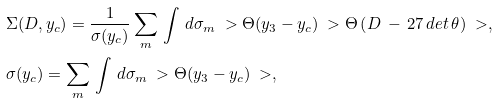<formula> <loc_0><loc_0><loc_500><loc_500>& \Sigma ( D , y _ { c } ) = \frac { 1 } { \sigma ( y _ { c } ) } \sum _ { m } \, \int \, { d \sigma _ { m } } \ > \Theta ( y _ { 3 } - y _ { c } ) \ > \Theta \left ( D \, - \, 2 7 \, d e t \, \theta \right ) \ > , \\ & \sigma ( y _ { c } ) = \sum _ { m } \, \int \, { d \sigma _ { m } } \ > \Theta ( y _ { 3 } - y _ { c } ) \ > ,</formula> 